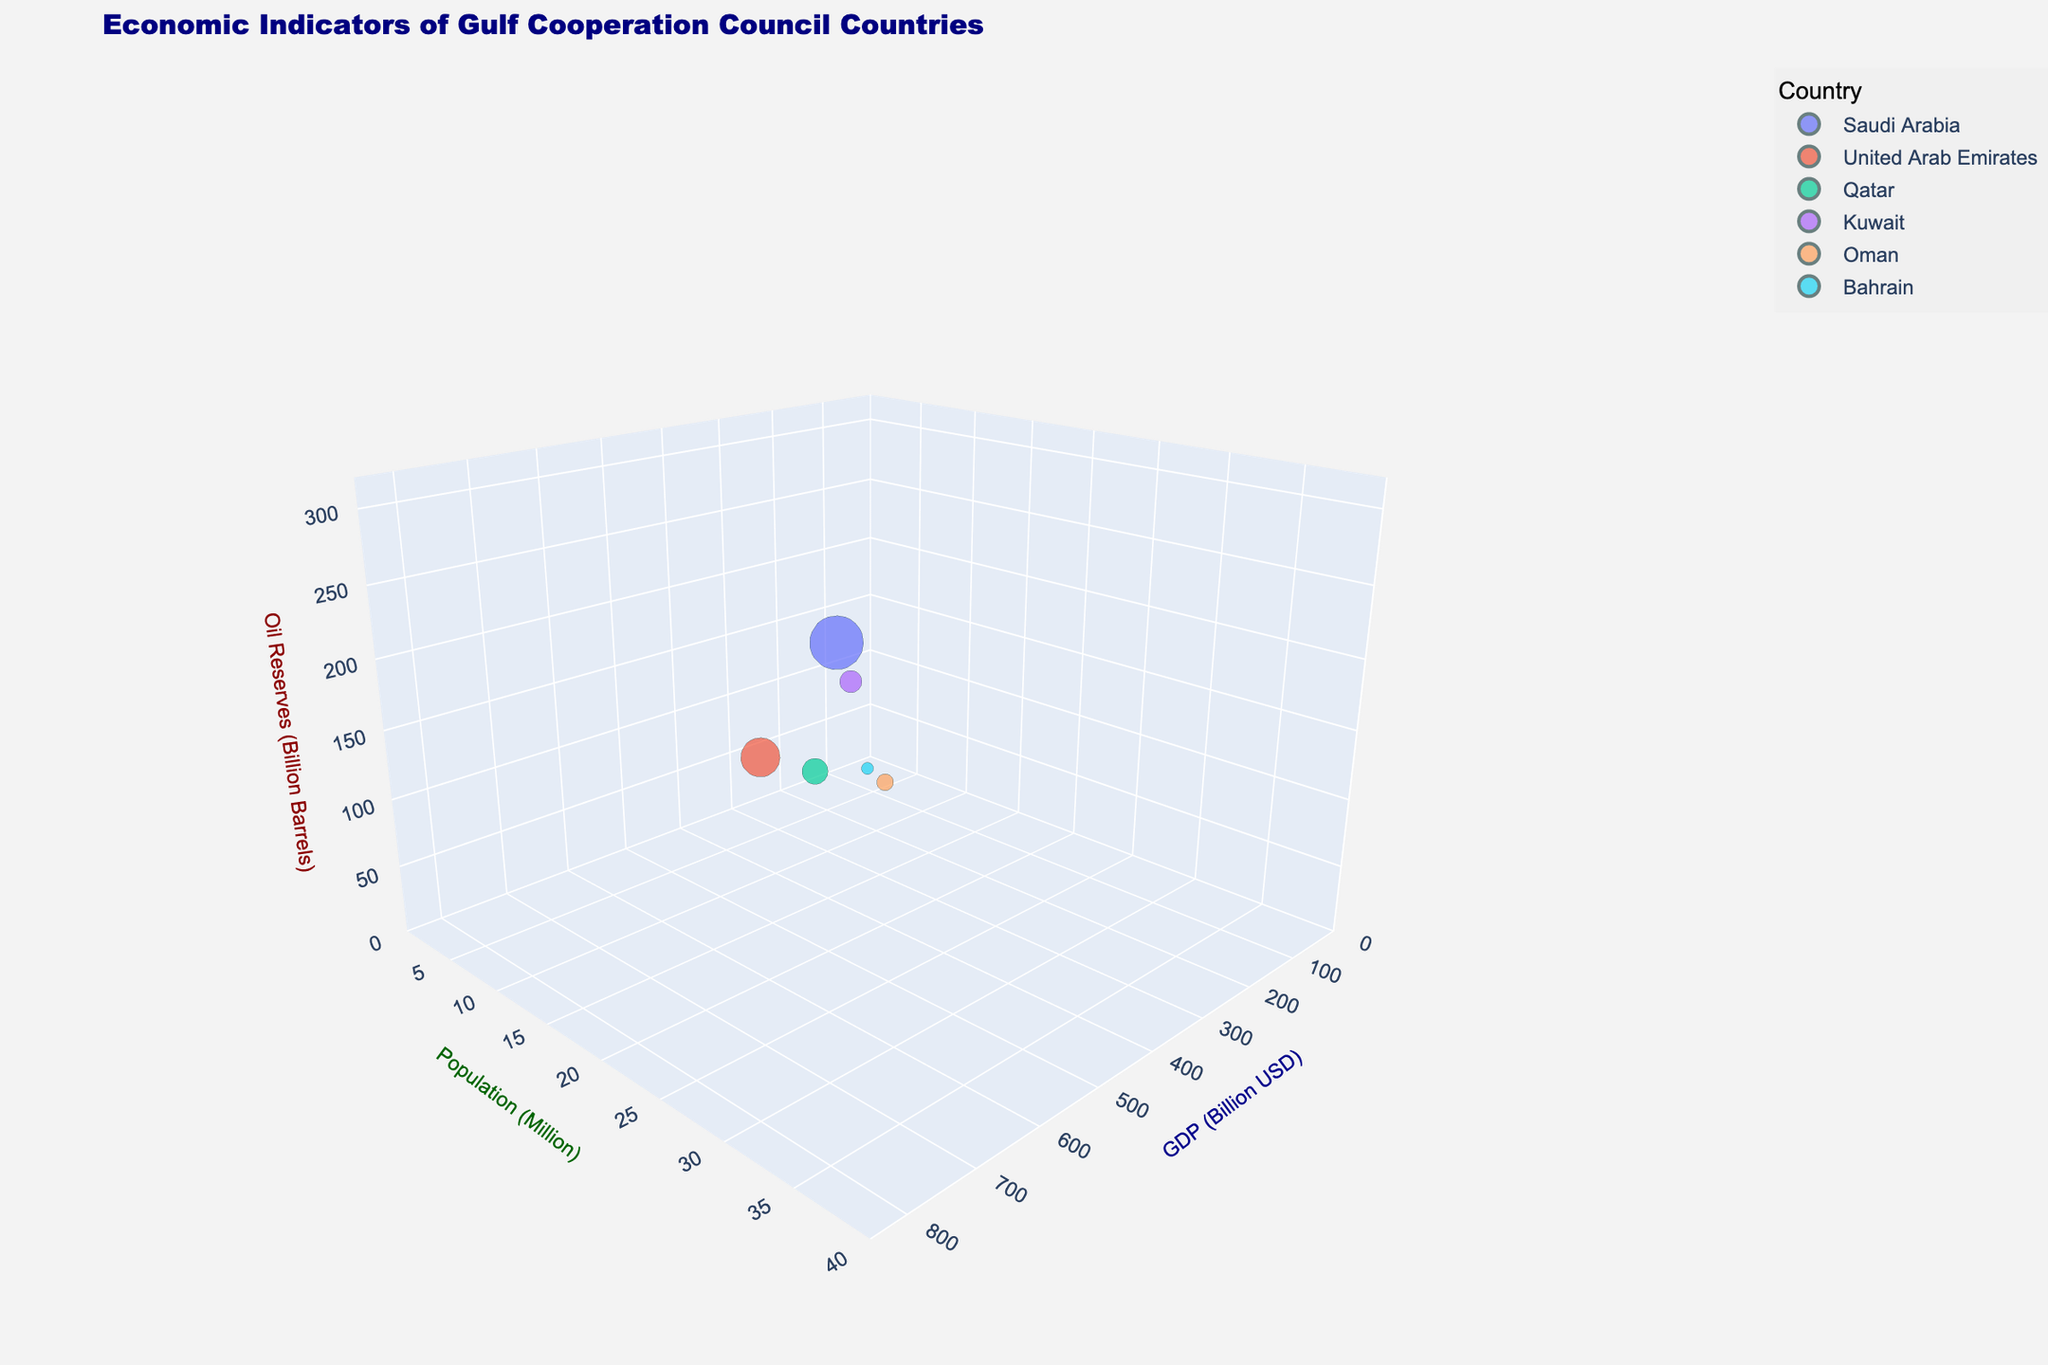What is the title of the figure? The title is located at the top of the figure and it is clearly indicated as the main label of the plot.
Answer: Economic Indicators of Gulf Cooperation Council Countries Which country has the highest GDP? By observing the x-axis (GDP in Billion USD) and the size of the bubbles, the largest bubble and the furthest point along the x-axis correspond to Saudi Arabia.
Answer: Saudi Arabia How many countries are represented in this chart? Each distinct color and label represent a different country, and there are six bubbles present.
Answer: Six Which country has the smallest population? By looking at the y-axis (Population in Million) and identifying the lowest point, Bahrain has the smallest population.
Answer: Bahrain What is the relationship between GDP and oil reserves among the countries? Observing the x-axis (GDP) and the z-axis (Oil Reserves), it is noticeable that countries with high GDPs such as Saudi Arabia and UAE also have larger oil reserves.
Answer: Countries with higher GDP tend to have larger oil reserves Which country has a higher population, Qatar or Kuwait? By comparing the y-axis values for Qatar and Kuwait, Kuwait's population is at a higher point on the y-axis.
Answer: Kuwait How does the size of the bubble relate to the GDP of the countries? The size of each bubble is proportional to the GDP value, meaning larger bubbles represent countries with higher GDP.
Answer: Larger bubbles represent higher GDP What is the average GDP of Oman, Qatar, and Bahrain? Adding the GDP values (76 + 183 + 39) and then dividing by the number of countries (3) gives the average GDP.
Answer: 99.33 Billion USD Which country has the second-largest oil reserves? By looking at the z-axis values for oil reserves, the second-largest value after Saudi Arabia's 297.5 billion barrels is Kuwait with 101.5 billion barrels.
Answer: Kuwait Is there any country with oil reserves less than 1 billion barrels? By observing the z-axis and the smallest bubble, Bahrain has oil reserves significantly less than 1 billion barrels.
Answer: Bahrain 